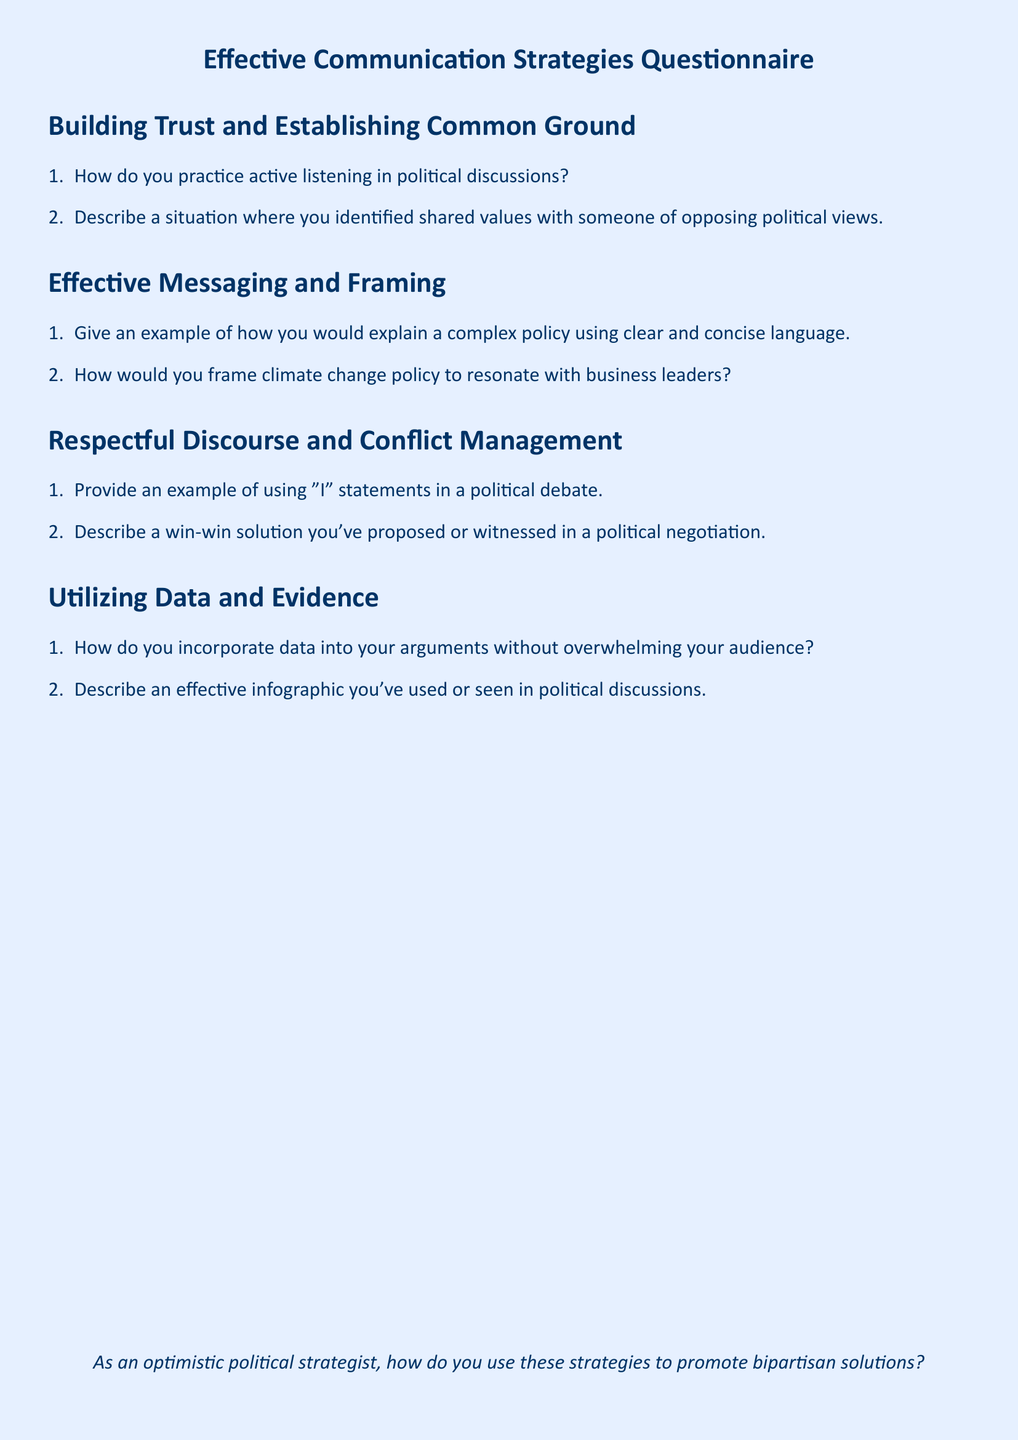What is the title of the document? The title of the document is stated prominently at the center of the first page.
Answer: Effective Communication Strategies Questionnaire How many sections are there in the document? The document consists of distinct sections that are clearly outlined.
Answer: Four What is the first section about? The first section's title indicates the focus of the content within it.
Answer: Building Trust and Establishing Common Ground What type of communication technique is addressed in the second question of the fourth section? The question is about how data is used in communication, which is a key aspect of the section's focus.
Answer: Infographic What is one technique mentioned for respectful discourse? The document provides an example of a communication approach that fosters respect in discussions.
Answer: "I" statements 